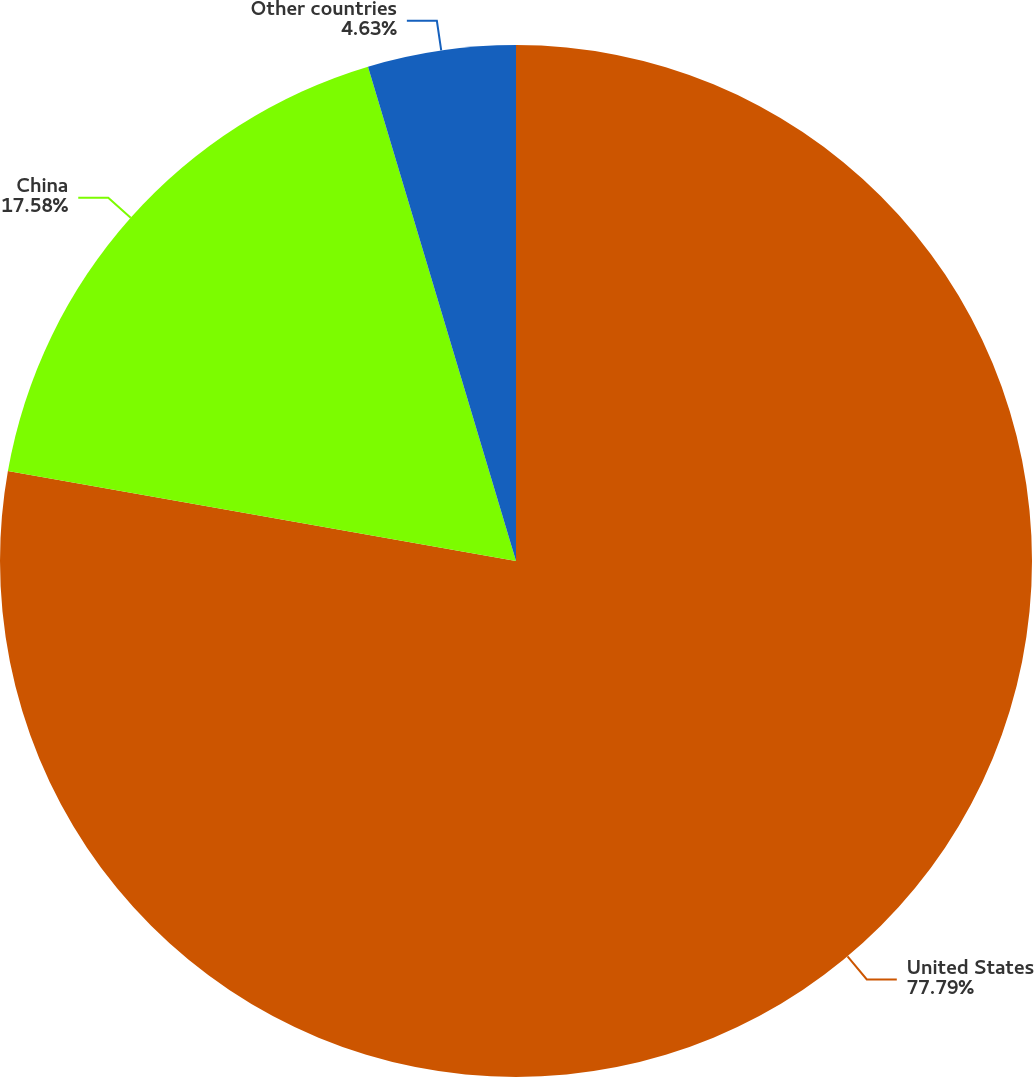Convert chart to OTSL. <chart><loc_0><loc_0><loc_500><loc_500><pie_chart><fcel>United States<fcel>China<fcel>Other countries<nl><fcel>77.79%<fcel>17.58%<fcel>4.63%<nl></chart> 